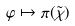<formula> <loc_0><loc_0><loc_500><loc_500>\varphi \mapsto \pi ( \tilde { \chi } )</formula> 